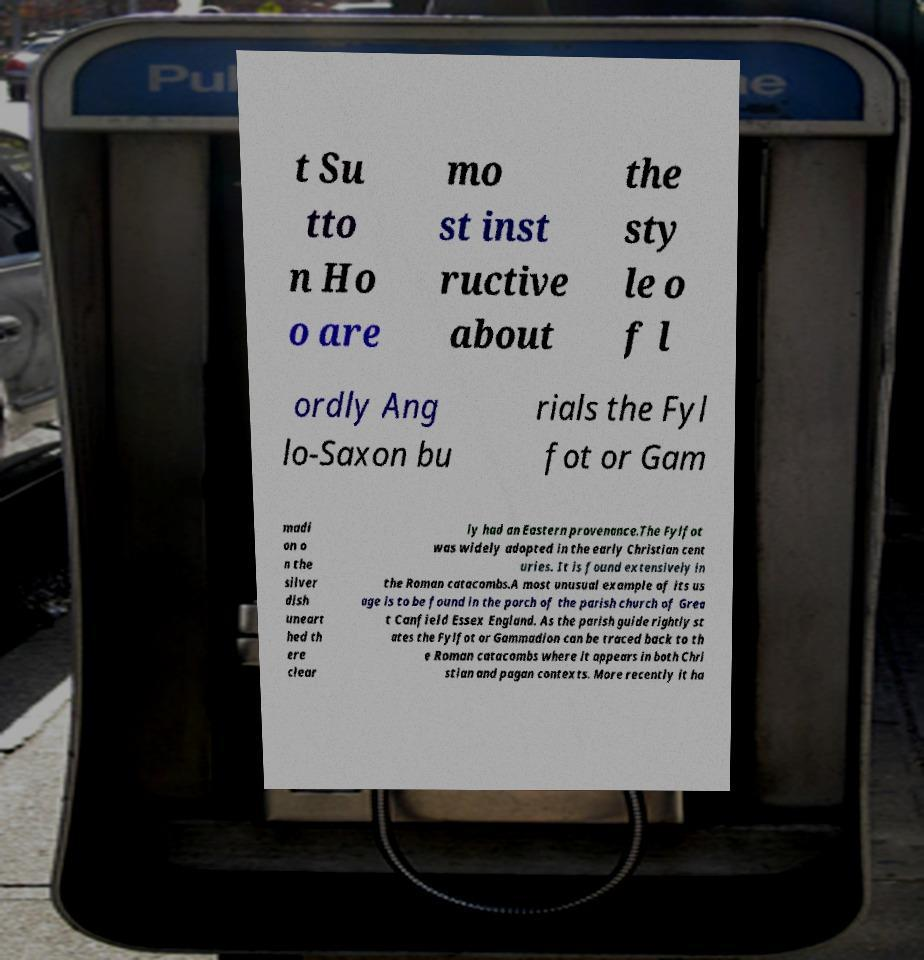Could you extract and type out the text from this image? t Su tto n Ho o are mo st inst ructive about the sty le o f l ordly Ang lo-Saxon bu rials the Fyl fot or Gam madi on o n the silver dish uneart hed th ere clear ly had an Eastern provenance.The Fylfot was widely adopted in the early Christian cent uries. It is found extensively in the Roman catacombs.A most unusual example of its us age is to be found in the porch of the parish church of Grea t Canfield Essex England. As the parish guide rightly st ates the Fylfot or Gammadion can be traced back to th e Roman catacombs where it appears in both Chri stian and pagan contexts. More recently it ha 